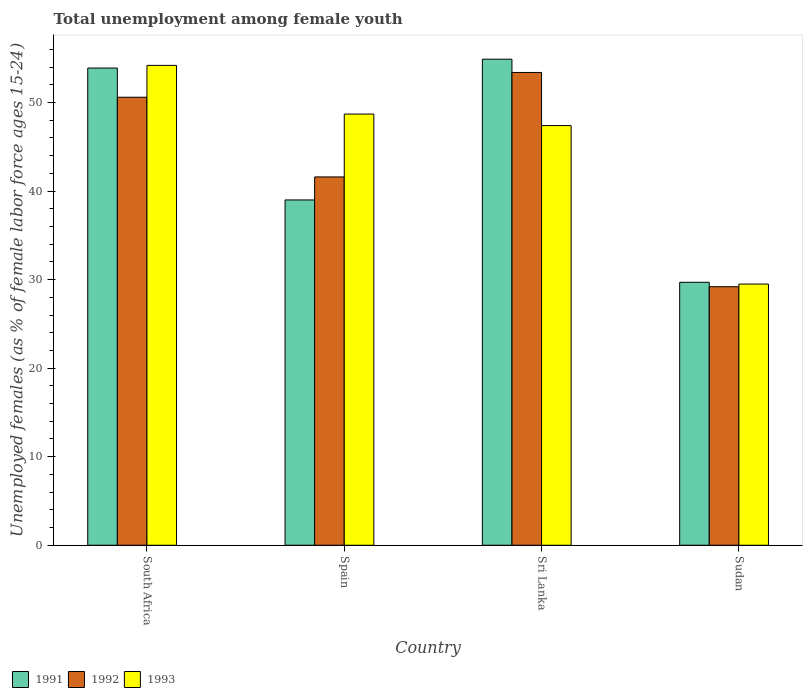How many different coloured bars are there?
Ensure brevity in your answer.  3. How many groups of bars are there?
Provide a succinct answer. 4. Are the number of bars per tick equal to the number of legend labels?
Offer a terse response. Yes. Are the number of bars on each tick of the X-axis equal?
Make the answer very short. Yes. What is the label of the 4th group of bars from the left?
Provide a short and direct response. Sudan. What is the percentage of unemployed females in in 1993 in South Africa?
Make the answer very short. 54.2. Across all countries, what is the maximum percentage of unemployed females in in 1993?
Offer a terse response. 54.2. Across all countries, what is the minimum percentage of unemployed females in in 1993?
Give a very brief answer. 29.5. In which country was the percentage of unemployed females in in 1993 maximum?
Make the answer very short. South Africa. In which country was the percentage of unemployed females in in 1993 minimum?
Provide a succinct answer. Sudan. What is the total percentage of unemployed females in in 1993 in the graph?
Offer a terse response. 179.8. What is the difference between the percentage of unemployed females in in 1991 in South Africa and that in Sudan?
Provide a short and direct response. 24.2. What is the difference between the percentage of unemployed females in in 1993 in Sudan and the percentage of unemployed females in in 1991 in South Africa?
Your answer should be compact. -24.4. What is the average percentage of unemployed females in in 1991 per country?
Give a very brief answer. 44.38. What is the difference between the percentage of unemployed females in of/in 1992 and percentage of unemployed females in of/in 1991 in South Africa?
Your answer should be compact. -3.3. What is the ratio of the percentage of unemployed females in in 1991 in South Africa to that in Sri Lanka?
Your response must be concise. 0.98. What is the difference between the highest and the lowest percentage of unemployed females in in 1993?
Ensure brevity in your answer.  24.7. In how many countries, is the percentage of unemployed females in in 1993 greater than the average percentage of unemployed females in in 1993 taken over all countries?
Give a very brief answer. 3. Is the sum of the percentage of unemployed females in in 1991 in South Africa and Spain greater than the maximum percentage of unemployed females in in 1992 across all countries?
Ensure brevity in your answer.  Yes. What does the 3rd bar from the left in Sri Lanka represents?
Provide a short and direct response. 1993. Is it the case that in every country, the sum of the percentage of unemployed females in in 1992 and percentage of unemployed females in in 1991 is greater than the percentage of unemployed females in in 1993?
Offer a very short reply. Yes. How many countries are there in the graph?
Make the answer very short. 4. Does the graph contain any zero values?
Offer a very short reply. No. Does the graph contain grids?
Offer a terse response. No. How are the legend labels stacked?
Give a very brief answer. Horizontal. What is the title of the graph?
Offer a very short reply. Total unemployment among female youth. Does "1983" appear as one of the legend labels in the graph?
Your answer should be very brief. No. What is the label or title of the Y-axis?
Offer a very short reply. Unemployed females (as % of female labor force ages 15-24). What is the Unemployed females (as % of female labor force ages 15-24) of 1991 in South Africa?
Ensure brevity in your answer.  53.9. What is the Unemployed females (as % of female labor force ages 15-24) of 1992 in South Africa?
Offer a very short reply. 50.6. What is the Unemployed females (as % of female labor force ages 15-24) of 1993 in South Africa?
Your response must be concise. 54.2. What is the Unemployed females (as % of female labor force ages 15-24) of 1992 in Spain?
Your answer should be very brief. 41.6. What is the Unemployed females (as % of female labor force ages 15-24) in 1993 in Spain?
Offer a terse response. 48.7. What is the Unemployed females (as % of female labor force ages 15-24) of 1991 in Sri Lanka?
Provide a short and direct response. 54.9. What is the Unemployed females (as % of female labor force ages 15-24) in 1992 in Sri Lanka?
Give a very brief answer. 53.4. What is the Unemployed females (as % of female labor force ages 15-24) in 1993 in Sri Lanka?
Your response must be concise. 47.4. What is the Unemployed females (as % of female labor force ages 15-24) in 1991 in Sudan?
Ensure brevity in your answer.  29.7. What is the Unemployed females (as % of female labor force ages 15-24) of 1992 in Sudan?
Give a very brief answer. 29.2. What is the Unemployed females (as % of female labor force ages 15-24) of 1993 in Sudan?
Ensure brevity in your answer.  29.5. Across all countries, what is the maximum Unemployed females (as % of female labor force ages 15-24) in 1991?
Give a very brief answer. 54.9. Across all countries, what is the maximum Unemployed females (as % of female labor force ages 15-24) in 1992?
Your answer should be very brief. 53.4. Across all countries, what is the maximum Unemployed females (as % of female labor force ages 15-24) in 1993?
Provide a succinct answer. 54.2. Across all countries, what is the minimum Unemployed females (as % of female labor force ages 15-24) in 1991?
Your response must be concise. 29.7. Across all countries, what is the minimum Unemployed females (as % of female labor force ages 15-24) of 1992?
Your answer should be compact. 29.2. Across all countries, what is the minimum Unemployed females (as % of female labor force ages 15-24) in 1993?
Your response must be concise. 29.5. What is the total Unemployed females (as % of female labor force ages 15-24) in 1991 in the graph?
Keep it short and to the point. 177.5. What is the total Unemployed females (as % of female labor force ages 15-24) in 1992 in the graph?
Your answer should be very brief. 174.8. What is the total Unemployed females (as % of female labor force ages 15-24) in 1993 in the graph?
Offer a very short reply. 179.8. What is the difference between the Unemployed females (as % of female labor force ages 15-24) of 1991 in South Africa and that in Sri Lanka?
Your answer should be very brief. -1. What is the difference between the Unemployed females (as % of female labor force ages 15-24) of 1992 in South Africa and that in Sri Lanka?
Provide a short and direct response. -2.8. What is the difference between the Unemployed females (as % of female labor force ages 15-24) in 1993 in South Africa and that in Sri Lanka?
Offer a very short reply. 6.8. What is the difference between the Unemployed females (as % of female labor force ages 15-24) in 1991 in South Africa and that in Sudan?
Your answer should be compact. 24.2. What is the difference between the Unemployed females (as % of female labor force ages 15-24) in 1992 in South Africa and that in Sudan?
Give a very brief answer. 21.4. What is the difference between the Unemployed females (as % of female labor force ages 15-24) of 1993 in South Africa and that in Sudan?
Ensure brevity in your answer.  24.7. What is the difference between the Unemployed females (as % of female labor force ages 15-24) of 1991 in Spain and that in Sri Lanka?
Your response must be concise. -15.9. What is the difference between the Unemployed females (as % of female labor force ages 15-24) in 1992 in Spain and that in Sudan?
Give a very brief answer. 12.4. What is the difference between the Unemployed females (as % of female labor force ages 15-24) of 1991 in Sri Lanka and that in Sudan?
Your answer should be very brief. 25.2. What is the difference between the Unemployed females (as % of female labor force ages 15-24) in 1992 in Sri Lanka and that in Sudan?
Ensure brevity in your answer.  24.2. What is the difference between the Unemployed females (as % of female labor force ages 15-24) in 1991 in South Africa and the Unemployed females (as % of female labor force ages 15-24) in 1992 in Sudan?
Your answer should be very brief. 24.7. What is the difference between the Unemployed females (as % of female labor force ages 15-24) of 1991 in South Africa and the Unemployed females (as % of female labor force ages 15-24) of 1993 in Sudan?
Your answer should be compact. 24.4. What is the difference between the Unemployed females (as % of female labor force ages 15-24) of 1992 in South Africa and the Unemployed females (as % of female labor force ages 15-24) of 1993 in Sudan?
Give a very brief answer. 21.1. What is the difference between the Unemployed females (as % of female labor force ages 15-24) of 1991 in Spain and the Unemployed females (as % of female labor force ages 15-24) of 1992 in Sri Lanka?
Provide a short and direct response. -14.4. What is the difference between the Unemployed females (as % of female labor force ages 15-24) of 1991 in Spain and the Unemployed females (as % of female labor force ages 15-24) of 1993 in Sudan?
Your response must be concise. 9.5. What is the difference between the Unemployed females (as % of female labor force ages 15-24) of 1991 in Sri Lanka and the Unemployed females (as % of female labor force ages 15-24) of 1992 in Sudan?
Offer a terse response. 25.7. What is the difference between the Unemployed females (as % of female labor force ages 15-24) of 1991 in Sri Lanka and the Unemployed females (as % of female labor force ages 15-24) of 1993 in Sudan?
Provide a short and direct response. 25.4. What is the difference between the Unemployed females (as % of female labor force ages 15-24) of 1992 in Sri Lanka and the Unemployed females (as % of female labor force ages 15-24) of 1993 in Sudan?
Give a very brief answer. 23.9. What is the average Unemployed females (as % of female labor force ages 15-24) of 1991 per country?
Ensure brevity in your answer.  44.38. What is the average Unemployed females (as % of female labor force ages 15-24) in 1992 per country?
Offer a terse response. 43.7. What is the average Unemployed females (as % of female labor force ages 15-24) in 1993 per country?
Your answer should be very brief. 44.95. What is the difference between the Unemployed females (as % of female labor force ages 15-24) of 1991 and Unemployed females (as % of female labor force ages 15-24) of 1992 in South Africa?
Make the answer very short. 3.3. What is the difference between the Unemployed females (as % of female labor force ages 15-24) in 1991 and Unemployed females (as % of female labor force ages 15-24) in 1993 in South Africa?
Provide a succinct answer. -0.3. What is the difference between the Unemployed females (as % of female labor force ages 15-24) of 1991 and Unemployed females (as % of female labor force ages 15-24) of 1993 in Spain?
Ensure brevity in your answer.  -9.7. What is the difference between the Unemployed females (as % of female labor force ages 15-24) in 1992 and Unemployed females (as % of female labor force ages 15-24) in 1993 in Spain?
Make the answer very short. -7.1. What is the difference between the Unemployed females (as % of female labor force ages 15-24) in 1991 and Unemployed females (as % of female labor force ages 15-24) in 1992 in Sri Lanka?
Give a very brief answer. 1.5. What is the difference between the Unemployed females (as % of female labor force ages 15-24) in 1991 and Unemployed females (as % of female labor force ages 15-24) in 1992 in Sudan?
Provide a succinct answer. 0.5. What is the difference between the Unemployed females (as % of female labor force ages 15-24) of 1992 and Unemployed females (as % of female labor force ages 15-24) of 1993 in Sudan?
Provide a short and direct response. -0.3. What is the ratio of the Unemployed females (as % of female labor force ages 15-24) in 1991 in South Africa to that in Spain?
Give a very brief answer. 1.38. What is the ratio of the Unemployed females (as % of female labor force ages 15-24) of 1992 in South Africa to that in Spain?
Your response must be concise. 1.22. What is the ratio of the Unemployed females (as % of female labor force ages 15-24) of 1993 in South Africa to that in Spain?
Your answer should be compact. 1.11. What is the ratio of the Unemployed females (as % of female labor force ages 15-24) of 1991 in South Africa to that in Sri Lanka?
Provide a succinct answer. 0.98. What is the ratio of the Unemployed females (as % of female labor force ages 15-24) in 1992 in South Africa to that in Sri Lanka?
Provide a succinct answer. 0.95. What is the ratio of the Unemployed females (as % of female labor force ages 15-24) of 1993 in South Africa to that in Sri Lanka?
Ensure brevity in your answer.  1.14. What is the ratio of the Unemployed females (as % of female labor force ages 15-24) of 1991 in South Africa to that in Sudan?
Your response must be concise. 1.81. What is the ratio of the Unemployed females (as % of female labor force ages 15-24) in 1992 in South Africa to that in Sudan?
Your answer should be compact. 1.73. What is the ratio of the Unemployed females (as % of female labor force ages 15-24) in 1993 in South Africa to that in Sudan?
Provide a succinct answer. 1.84. What is the ratio of the Unemployed females (as % of female labor force ages 15-24) of 1991 in Spain to that in Sri Lanka?
Offer a very short reply. 0.71. What is the ratio of the Unemployed females (as % of female labor force ages 15-24) in 1992 in Spain to that in Sri Lanka?
Keep it short and to the point. 0.78. What is the ratio of the Unemployed females (as % of female labor force ages 15-24) in 1993 in Spain to that in Sri Lanka?
Give a very brief answer. 1.03. What is the ratio of the Unemployed females (as % of female labor force ages 15-24) of 1991 in Spain to that in Sudan?
Make the answer very short. 1.31. What is the ratio of the Unemployed females (as % of female labor force ages 15-24) of 1992 in Spain to that in Sudan?
Offer a terse response. 1.42. What is the ratio of the Unemployed females (as % of female labor force ages 15-24) of 1993 in Spain to that in Sudan?
Provide a succinct answer. 1.65. What is the ratio of the Unemployed females (as % of female labor force ages 15-24) in 1991 in Sri Lanka to that in Sudan?
Offer a very short reply. 1.85. What is the ratio of the Unemployed females (as % of female labor force ages 15-24) of 1992 in Sri Lanka to that in Sudan?
Your response must be concise. 1.83. What is the ratio of the Unemployed females (as % of female labor force ages 15-24) of 1993 in Sri Lanka to that in Sudan?
Keep it short and to the point. 1.61. What is the difference between the highest and the second highest Unemployed females (as % of female labor force ages 15-24) of 1991?
Ensure brevity in your answer.  1. What is the difference between the highest and the second highest Unemployed females (as % of female labor force ages 15-24) in 1992?
Keep it short and to the point. 2.8. What is the difference between the highest and the second highest Unemployed females (as % of female labor force ages 15-24) in 1993?
Your answer should be compact. 5.5. What is the difference between the highest and the lowest Unemployed females (as % of female labor force ages 15-24) in 1991?
Offer a terse response. 25.2. What is the difference between the highest and the lowest Unemployed females (as % of female labor force ages 15-24) in 1992?
Your response must be concise. 24.2. What is the difference between the highest and the lowest Unemployed females (as % of female labor force ages 15-24) of 1993?
Give a very brief answer. 24.7. 